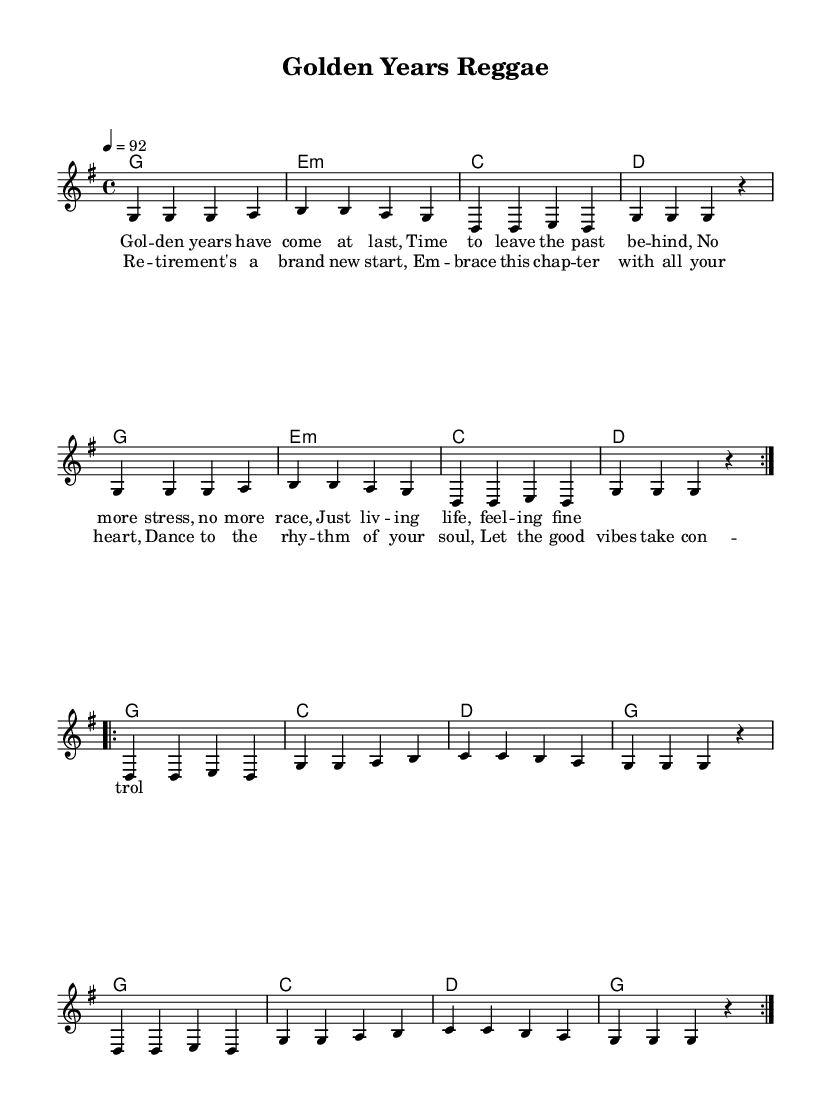What is the key signature of this music? The key signature is G major, which has one sharp (F#). This can be determined from the global section of the code where it specifies "g \major."
Answer: G major What is the time signature of this music? The time signature is 4/4, indicated in the global section of the code as "\time 4/4." This means there are four beats in each measure and the quarter note gets one beat.
Answer: 4/4 What is the tempo marking for this piece? The tempo marking, which indicates the speed of the piece, is set at 92 beats per minute in the global section of the code ("4 = 92"). This denotes the number of beats per minute to be played.
Answer: 92 How many verses are present in this piece's lyrics? There is one verse labeled "verseOne" and a chorus in the lyrics section. The "verseOne" section contains lyrics that tell a story of retirement.
Answer: One verse What are the primary themes reflected in the lyrics? The lyrics focus on themes of reflection on retirement and embracing new beginnings, as indicated by phrases like "Time to leave the past behind" and "Embrace this chapter with all your heart." This showcases feelings of joy and optimism about the new phase of life.
Answer: Joy and optimism What is the predominant harmonic structure used in the song? The predominant harmonic structure consists of simple major chords such as G, C, and D, which are staples in reggae music. By analyzing the "harmonies" section, we can see the repeated use of these chords.
Answer: Major chords What rhythmic style is characteristic of reggae music, as seen in this piece? The rhythmic style characteristic of reggae music includes a strong emphasis on the off-beat, known as the "one drop" rhythm. In this piece, the melody's rhythmic pattern reflects this reggae style with its laid-back groove.
Answer: Off-beat rhythm 